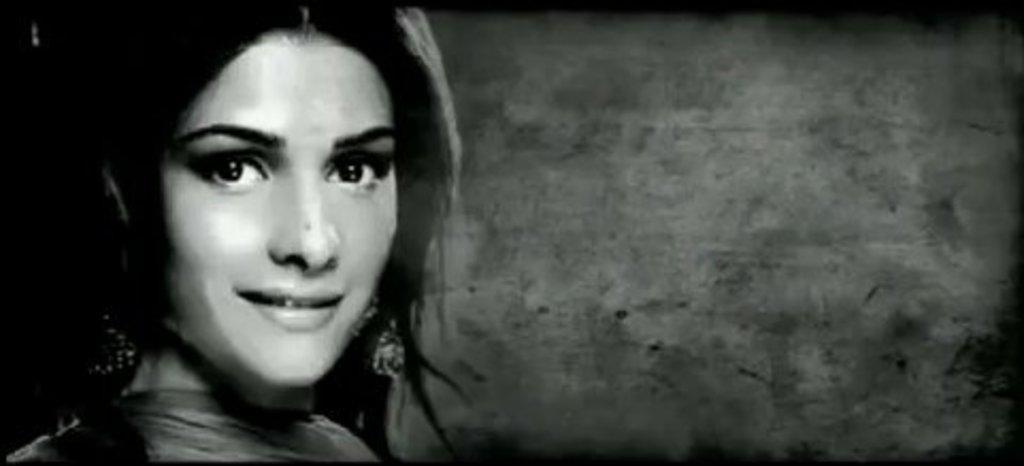Can you describe this image briefly? In the picture I can see a woman on the left side and there is a smile on her face. 